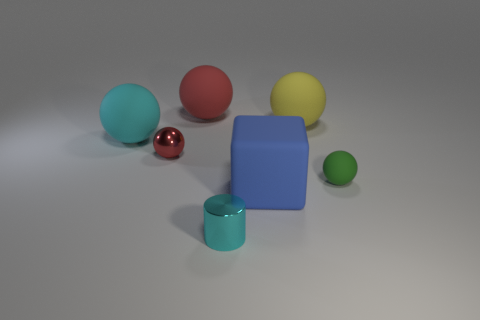How many objects appear to be reflective? There are two objects that appear to be reflective. One is a chrome or metallic sphere and the other is a green sphere with a shiny surface. 